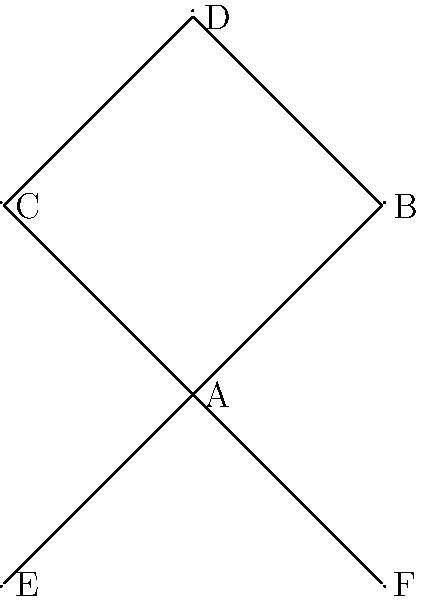Consider the graph representing international agreements between countries. The group $G$ of diplomatic actions acts on this set of agreements. If $G$ has order 6 and the stabilizer of agreement A has order 2, how many agreements are in the orbit of A under the action of $G$? To solve this problem, we'll use the Orbit-Stabilizer Theorem and our knowledge of group actions:

1) The Orbit-Stabilizer Theorem states that for a group $G$ acting on a set $X$, and an element $x \in X$:

   $|G| = |Stab_G(x)| \cdot |Orb_G(x)|$

   Where $|G|$ is the order of the group, $|Stab_G(x)|$ is the order of the stabilizer of $x$, and $|Orb_G(x)|$ is the size of the orbit of $x$.

2) We're given that:
   - $|G| = 6$ (the order of the group is 6)
   - $|Stab_G(A)| = 2$ (the order of the stabilizer of agreement A is 2)

3) Let's substitute these values into the Orbit-Stabilizer Theorem:

   $6 = 2 \cdot |Orb_G(A)|$

4) Solving for $|Orb_G(A)|$:

   $|Orb_G(A)| = 6 / 2 = 3$

Therefore, the orbit of agreement A under the action of $G$ contains 3 agreements.
Answer: 3 